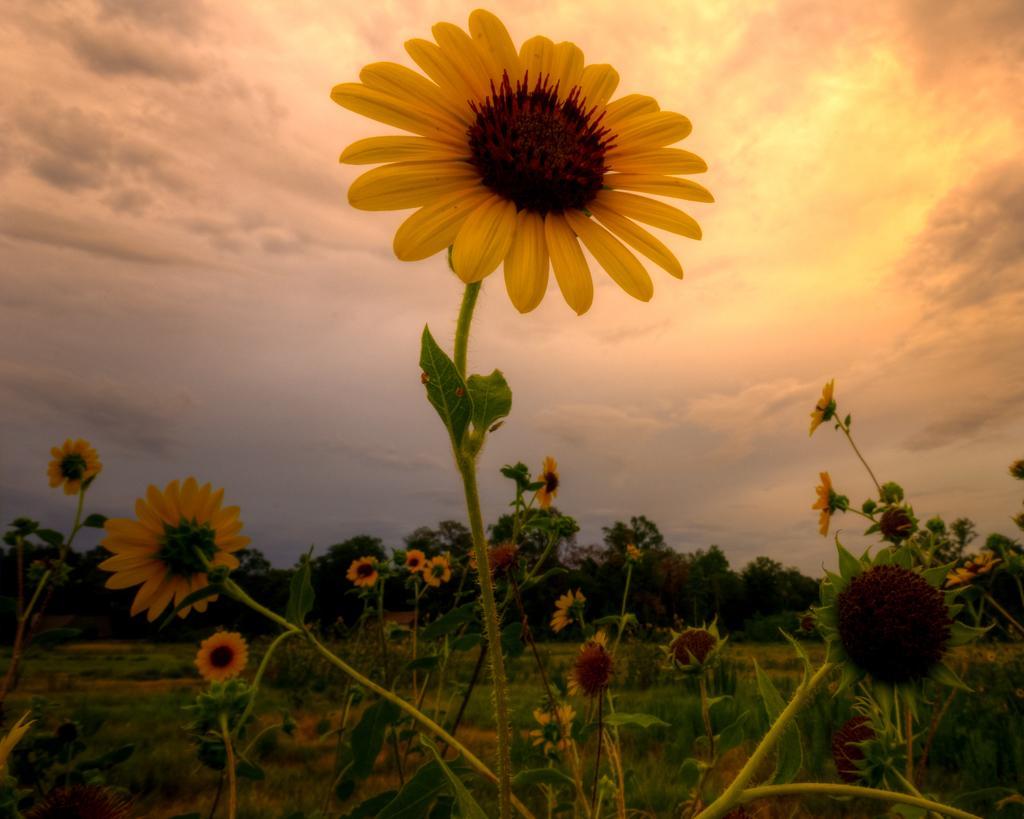Can you describe this image briefly? In this picture we can see sunflowers in the farmland. In the background we can see many trees. At the top we can see sky and clouds. 